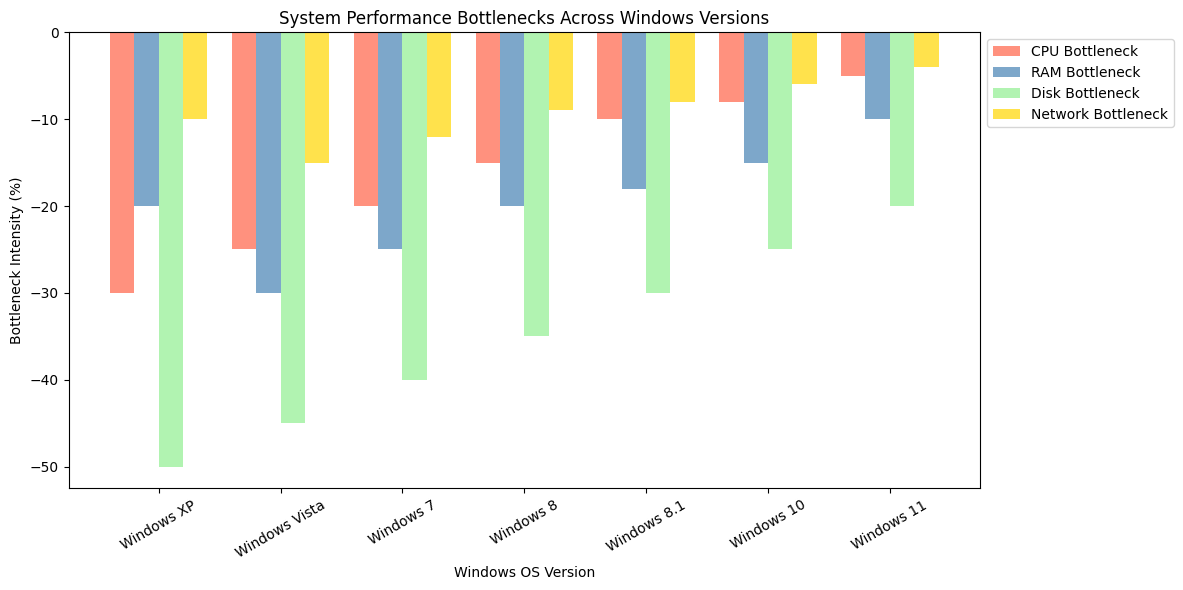1. Which Windows version has the lowest CPU bottleneck? By comparing the heights of the red bars (CPU bottlenecks) across all Windows versions, the shortest red bar corresponds to the Windows 11 version.
Answer: Windows 11 2. Compare the RAM bottleneck between Windows XP and Windows Vista. Which one is higher? The blue bar for RAM bottleneck in Windows XP is at -20%, and for Windows Vista, it is at -30%. Since -30% represents a greater reduction, Windows Vista has a higher RAM bottleneck.
Answer: Windows Vista 4. Which Windows version shows the least improvement in Network bottleneck compared to its predecessor? Comparing the yellow bars between consecutive Windows versions, Windows 8.1 shows a change of -1% from Windows 8 (-9% to -8%), which is the least improvement.
Answer: Windows 8.1 5. How has the total bottleneck across all categories changed from Windows XP to Windows 7? Summing up the bottlenecks for Windows XP: -30 + -20 + -50 + -10 = -110%. For Windows 7: -20 + -25 + -40 + -12 = -97%. The change is -110% - (-97%) = -13%.
Answer: -13% 6. Compare the total bottleneck values for Windows 8 and Windows 10. Which one has fewer bottlenecks? Summing up the bottlenecks for Windows 8: -15 + -20 + -35 + -9 = -79%. For Windows 10: -8 + -15 + -25 + -6 = -54%. Windows 10 has fewer bottlenecks.
Answer: Windows 10 7. What is the average CPU bottleneck for Windows 8, 8.1, and 10? Summing up the CPU bottlenecks for Windows 8, 8.1, and 10: -15 + -10 + -8 = -33%. The average is -33% / 3 = -11%.
Answer: -11% 8. Which category has the largest overall improvement across all Windows versions? The overall improvements are: CPU from -30% to -5% (25%), RAM from -20% to -10% (10%), Disk from -50% to -20% (30%), Network from -10% to -4% (6%). The largest improvement is in Disk.
Answer: Disk 9. Which Windows version has balanced bottlenecks across all categories? A balanced bottleneck would have the smallest variance between categories for a given version. Windows 11 has bottlenecks: CPU (-5%), RAM (-10%), Disk (-20%), Network (-4%), showing relatively less variation.
Answer: Windows 11 10. How much has the Network bottleneck decreased from the worst to the best performing Windows version? The worst Network bottleneck is Windows XP at -10%, and the best is Windows 11 at -4%. The decrease is -10% - (-4%) = -6%.
Answer: 6% 